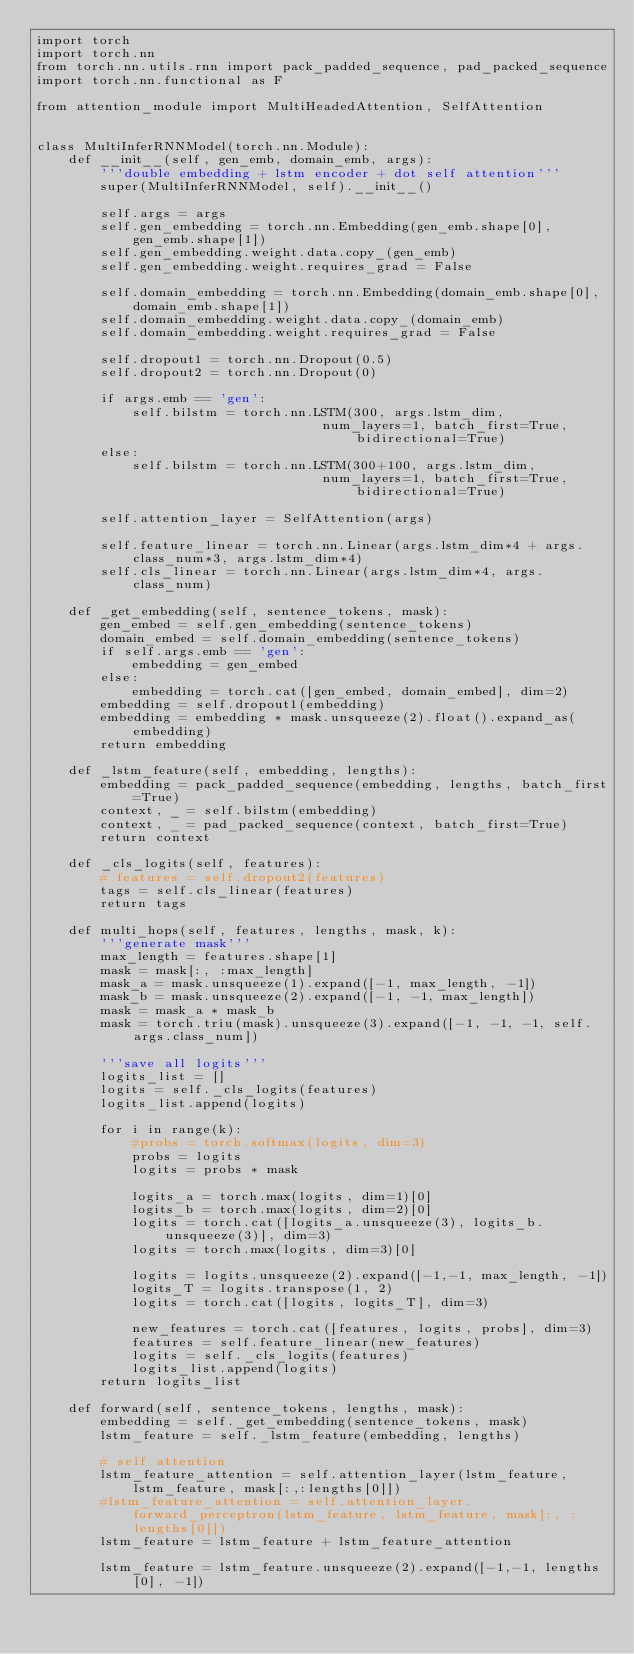<code> <loc_0><loc_0><loc_500><loc_500><_Python_>import torch
import torch.nn
from torch.nn.utils.rnn import pack_padded_sequence, pad_packed_sequence
import torch.nn.functional as F

from attention_module import MultiHeadedAttention, SelfAttention


class MultiInferRNNModel(torch.nn.Module):
	def __init__(self, gen_emb, domain_emb, args):
		'''double embedding + lstm encoder + dot self attention'''
		super(MultiInferRNNModel, self).__init__()

		self.args = args
		self.gen_embedding = torch.nn.Embedding(gen_emb.shape[0], gen_emb.shape[1])
		self.gen_embedding.weight.data.copy_(gen_emb)
		self.gen_embedding.weight.requires_grad = False

		self.domain_embedding = torch.nn.Embedding(domain_emb.shape[0], domain_emb.shape[1])
		self.domain_embedding.weight.data.copy_(domain_emb)
		self.domain_embedding.weight.requires_grad = False

		self.dropout1 = torch.nn.Dropout(0.5)
		self.dropout2 = torch.nn.Dropout(0)

		if args.emb == 'gen':
			self.bilstm = torch.nn.LSTM(300, args.lstm_dim,
									num_layers=1, batch_first=True, bidirectional=True)
		else:
			self.bilstm = torch.nn.LSTM(300+100, args.lstm_dim,
									num_layers=1, batch_first=True, bidirectional=True)

		self.attention_layer = SelfAttention(args)

		self.feature_linear = torch.nn.Linear(args.lstm_dim*4 + args.class_num*3, args.lstm_dim*4)
		self.cls_linear = torch.nn.Linear(args.lstm_dim*4, args.class_num)

	def _get_embedding(self, sentence_tokens, mask):
		gen_embed = self.gen_embedding(sentence_tokens)
		domain_embed = self.domain_embedding(sentence_tokens)
		if self.args.emb == 'gen':
			embedding = gen_embed
		else:
			embedding = torch.cat([gen_embed, domain_embed], dim=2)
		embedding = self.dropout1(embedding)
		embedding = embedding * mask.unsqueeze(2).float().expand_as(embedding)
		return embedding

	def _lstm_feature(self, embedding, lengths):
		embedding = pack_padded_sequence(embedding, lengths, batch_first=True)
		context, _ = self.bilstm(embedding)
		context, _ = pad_packed_sequence(context, batch_first=True)
		return context

	def _cls_logits(self, features):
		# features = self.dropout2(features)
		tags = self.cls_linear(features)
		return tags

	def multi_hops(self, features, lengths, mask, k):
		'''generate mask'''
		max_length = features.shape[1]
		mask = mask[:, :max_length]
		mask_a = mask.unsqueeze(1).expand([-1, max_length, -1])
		mask_b = mask.unsqueeze(2).expand([-1, -1, max_length])
		mask = mask_a * mask_b
		mask = torch.triu(mask).unsqueeze(3).expand([-1, -1, -1, self.args.class_num])

		'''save all logits'''
		logits_list = []
		logits = self._cls_logits(features)
		logits_list.append(logits)

		for i in range(k):
			#probs = torch.softmax(logits, dim=3)
			probs = logits
			logits = probs * mask

			logits_a = torch.max(logits, dim=1)[0]
			logits_b = torch.max(logits, dim=2)[0]
			logits = torch.cat([logits_a.unsqueeze(3), logits_b.unsqueeze(3)], dim=3)
			logits = torch.max(logits, dim=3)[0]

			logits = logits.unsqueeze(2).expand([-1,-1, max_length, -1])
			logits_T = logits.transpose(1, 2)
			logits = torch.cat([logits, logits_T], dim=3)

			new_features = torch.cat([features, logits, probs], dim=3)
			features = self.feature_linear(new_features)
			logits = self._cls_logits(features)
			logits_list.append(logits)
		return logits_list

	def forward(self, sentence_tokens, lengths, mask):
		embedding = self._get_embedding(sentence_tokens, mask)
		lstm_feature = self._lstm_feature(embedding, lengths)

		# self attention
		lstm_feature_attention = self.attention_layer(lstm_feature, lstm_feature, mask[:,:lengths[0]])
		#lstm_feature_attention = self.attention_layer.forward_perceptron(lstm_feature, lstm_feature, mask[:, :lengths[0]])
		lstm_feature = lstm_feature + lstm_feature_attention

		lstm_feature = lstm_feature.unsqueeze(2).expand([-1,-1, lengths[0], -1])</code> 